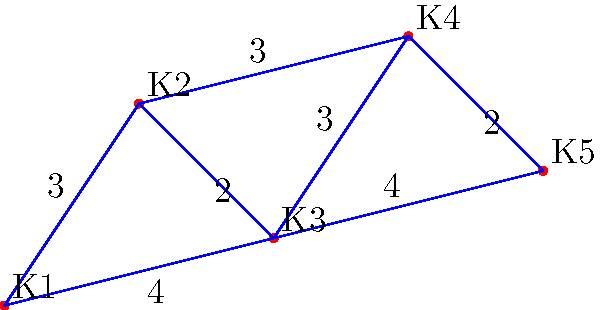At the animal shelter, there are 5 kennels (K1 to K5) connected by paths. The numbers on the paths represent the distance between kennels in minutes. What is the shortest time it would take to visit all the kennels, starting from K1 and ending at K5? To find the shortest path visiting all kennels from K1 to K5, we need to consider all possible routes:

1. K1 → K2 → K3 → K4 → K5:
   Time = 3 + 2 + 3 + 2 = 10 minutes

2. K1 → K2 → K3 → K5:
   Time = 3 + 2 + 4 = 9 minutes

3. K1 → K2 → K4 → K5:
   Time = 3 + 3 + 2 = 8 minutes

4. K1 → K3 → K4 → K5:
   Time = 4 + 3 + 2 = 9 minutes

5. K1 → K3 → K5:
   Time = 4 + 4 = 8 minutes

The shortest paths are:
- K1 → K2 → K4 → K5
- K1 → K3 → K5

Both take 8 minutes, which is the shortest possible time to visit all kennels from K1 to K5.
Answer: 8 minutes 